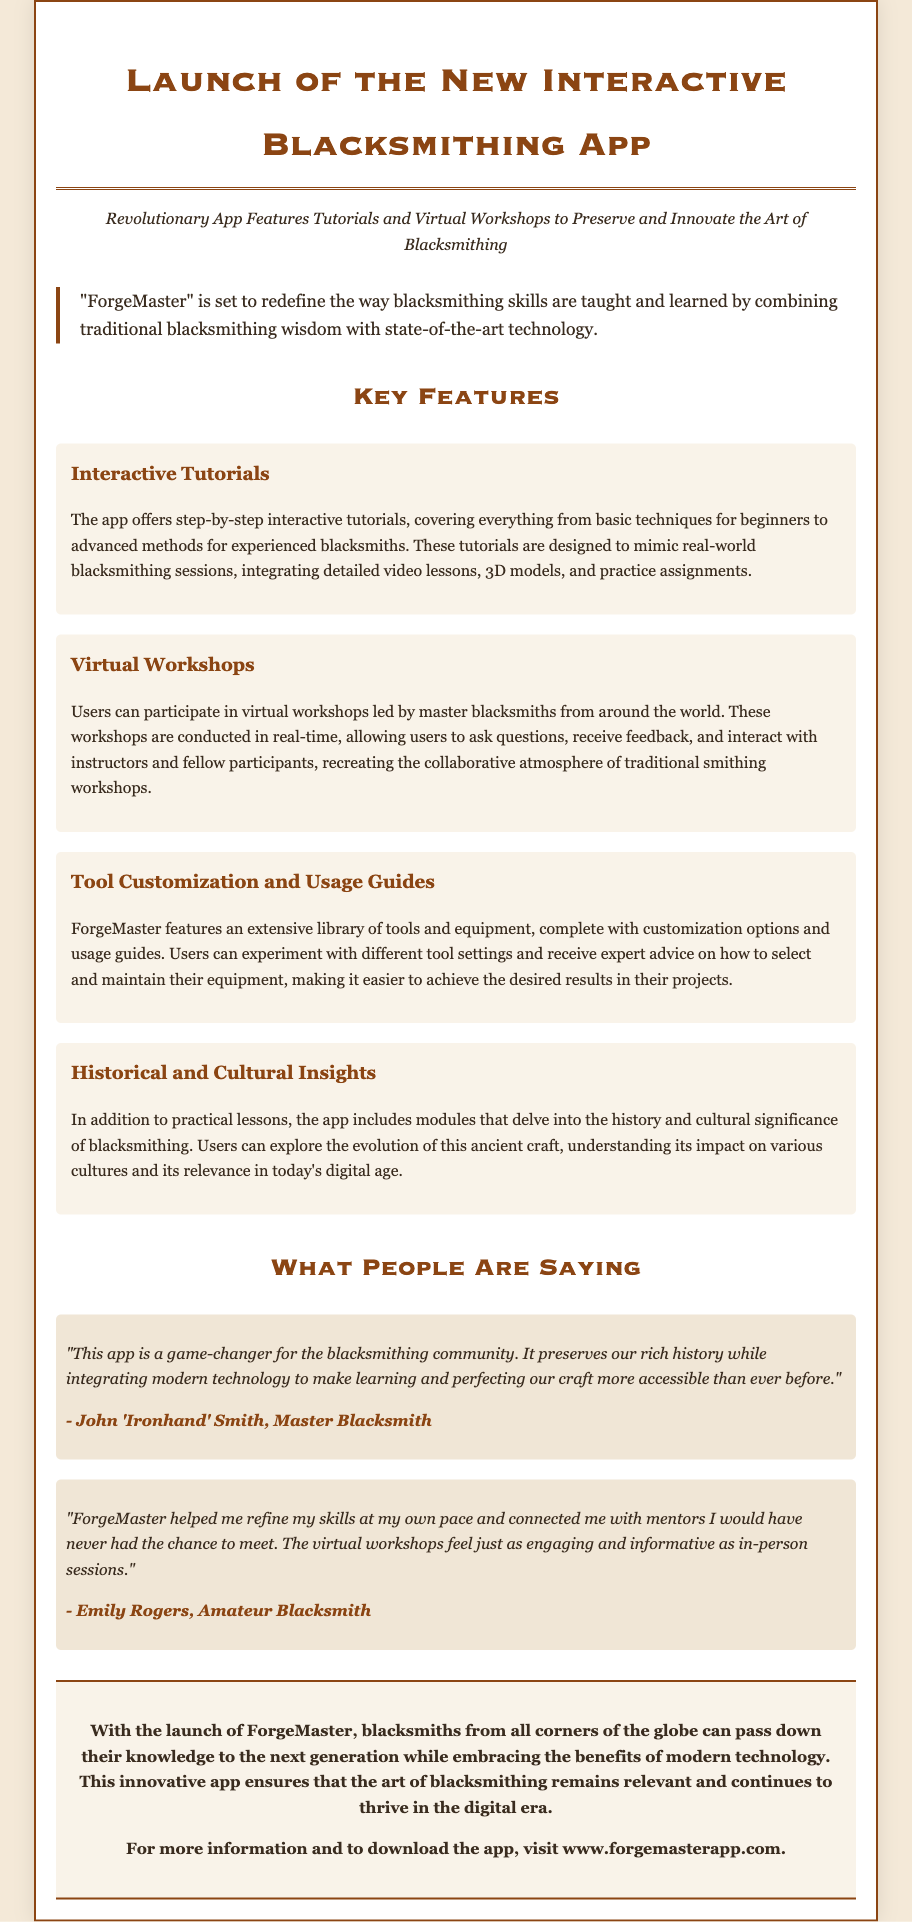What is the name of the app? The app is named "ForgeMaster" as mentioned in the title and introduction.
Answer: ForgeMaster What does the app offer for users? The app offers interactive tutorials, virtual workshops, tool customization guides, and historical insights.
Answer: Interactive tutorials, virtual workshops, tool customization guides, historical insights Who leads the virtual workshops? The workshops are led by master blacksmiths from around the world.
Answer: Master blacksmiths What is one benefit of the ForgeMaster app according to John 'Ironhand' Smith? John 'Ironhand' Smith mentions that the app integrates modern technology to make learning more accessible.
Answer: Makes learning more accessible What is the website to download the app? The website mentioned for more information and to download the app is www.forgemasterapp.com.
Answer: www.forgemasterapp.com How do participants interact during virtual workshops? Participants ask questions, receive feedback, and interact with instructors and fellow participants in real-time.
Answer: In real-time What type of insight does the app provide regarding blacksmithing? The app includes modules that delve into the history and cultural significance of blacksmithing.
Answer: History and cultural significance How does Emily Rogers describe her experience with the app? Emily Rogers describes the app as a tool that helped her refine her skills at her own pace and connect with mentors.
Answer: Refine skills and connect with mentors 